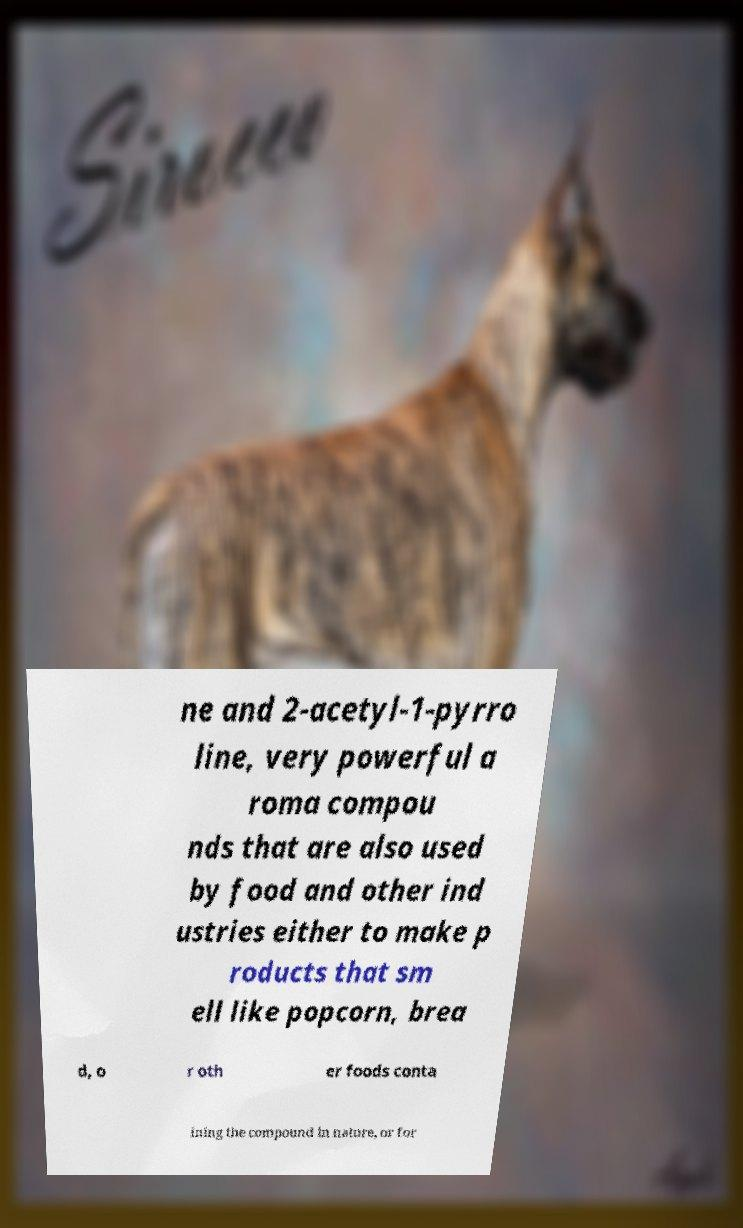I need the written content from this picture converted into text. Can you do that? ne and 2-acetyl-1-pyrro line, very powerful a roma compou nds that are also used by food and other ind ustries either to make p roducts that sm ell like popcorn, brea d, o r oth er foods conta ining the compound in nature, or for 